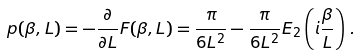<formula> <loc_0><loc_0><loc_500><loc_500>p ( \beta , L ) = - \frac { \partial } { \partial L } F ( \beta , L ) = \frac { \pi } { 6 L ^ { 2 } } - \frac { \pi } { 6 L ^ { 2 } } E _ { 2 } \left ( i \frac { \beta } { L } \right ) \, .</formula> 